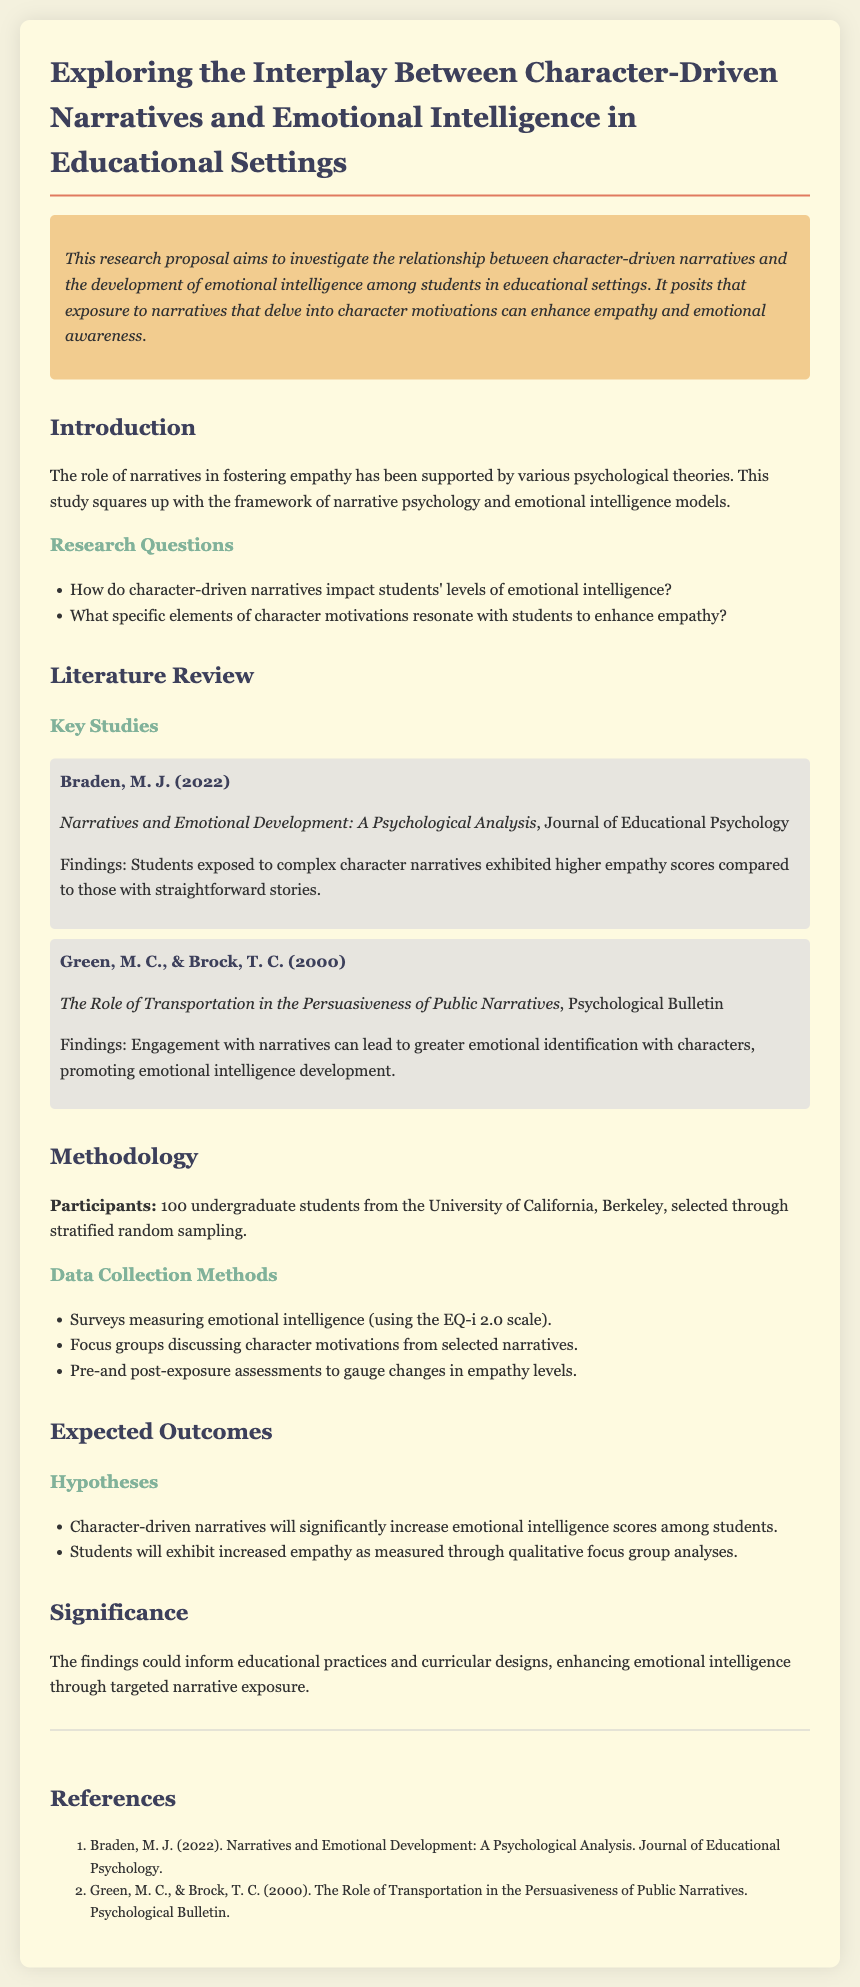What is the title of the research proposal? The title of the research proposal is found in the document header.
Answer: Exploring the Interplay Between Character-Driven Narratives and Emotional Intelligence in Educational Settings How many undergraduate students are participants in the study? The number of participants is specified in the Methodology section of the document.
Answer: 100 What scale is used to measure emotional intelligence? The document mentions a specific scale used for measuring emotional intelligence in the Data Collection Methods section.
Answer: EQ-i 2.0 scale Who conducted the study on narratives and emotional development? The author of the key study is listed in the Literature Review section of the document.
Answer: Braden, M. J What is the first hypothesis regarding character-driven narratives? The document lists hypotheses under the Expected Outcomes section, detailing the effects of character-driven narratives.
Answer: Character-driven narratives will significantly increase emotional intelligence scores among students What psychological framework aligns with this study? The psychological framework is mentioned in the Introduction section of the document.
Answer: Narrative psychology and emotional intelligence models What year was the study by Green and Brock published? The publication year for the key study by Green and Brock is found in the Literature Review section.
Answer: 2000 What is the expected outcome regarding empathy levels? The expected outcome is outlined in the hypotheses under the Expected Outcomes section of the document.
Answer: Increased empathy as measured through qualitative focus group analyses 